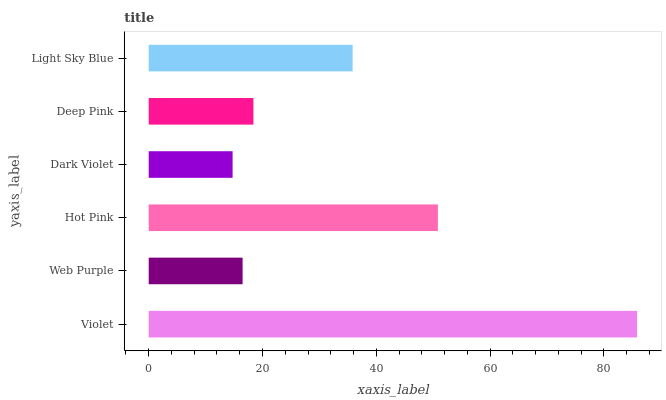Is Dark Violet the minimum?
Answer yes or no. Yes. Is Violet the maximum?
Answer yes or no. Yes. Is Web Purple the minimum?
Answer yes or no. No. Is Web Purple the maximum?
Answer yes or no. No. Is Violet greater than Web Purple?
Answer yes or no. Yes. Is Web Purple less than Violet?
Answer yes or no. Yes. Is Web Purple greater than Violet?
Answer yes or no. No. Is Violet less than Web Purple?
Answer yes or no. No. Is Light Sky Blue the high median?
Answer yes or no. Yes. Is Deep Pink the low median?
Answer yes or no. Yes. Is Deep Pink the high median?
Answer yes or no. No. Is Light Sky Blue the low median?
Answer yes or no. No. 